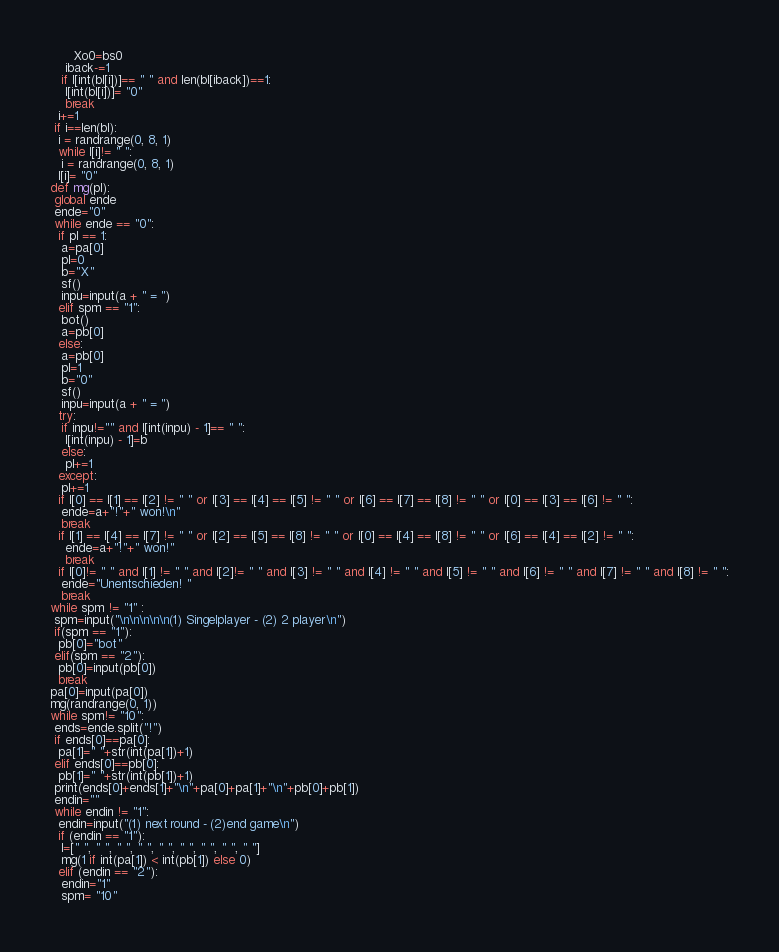<code> <loc_0><loc_0><loc_500><loc_500><_Python_>      Xo0=bs0
    iback-=1
   if l[int(bl[i])]== " " and len(bl[iback])==1:
    l[int(bl[i])]= "0"
    break
  i+=1
 if i==len(bl):
  i = randrange(0, 8, 1)
  while l[i]!= " ":
   i = randrange(0, 8, 1)
  l[i]= "0"
def mg(pl):
 global ende
 ende="0"
 while ende == "0":
  if pl == 1:
   a=pa[0]
   pl=0
   b="X"
   sf()
   inpu=input(a + " = ")
  elif spm == "1":
   bot()
   a=pb[0]
  else:
   a=pb[0]
   pl=1
   b="0"
   sf()
   inpu=input(a + " = ")
  try:
   if inpu!="" and l[int(inpu) - 1]== " ":
    l[int(inpu) - 1]=b
   else:
    pl+=1
  except:
   pl+=1
  if l[0] == l[1] == l[2] != " " or l[3] == l[4] == l[5] != " " or l[6] == l[7] == l[8] != " " or l[0] == l[3] == l[6] != " ":
   ende=a+"!"+" won!\n"
   break
  if l[1] == l[4] == l[7] != " " or l[2] == l[5] == l[8] != " " or l[0] == l[4] == l[8] != " " or l[6] == l[4] == l[2] != " ":
    ende=a+"!"+" won!"
    break
  if l[0]!= " " and l[1] != " " and l[2]!= " " and l[3] != " " and l[4] != " " and l[5] != " " and l[6] != " " and l[7] != " " and l[8] != " ":
   ende="Unentschieden! "
   break
while spm != "1" :
 spm=input("\n\n\n\n\n(1) Singelplayer - (2) 2 player\n")
 if(spm == "1"):
  pb[0]="bot"
 elif(spm == "2"):
  pb[0]=input(pb[0])
  break
pa[0]=input(pa[0])
mg(randrange(0, 1))
while spm!= "10":
 ends=ende.split("!")
 if ends[0]==pa[0]:
  pa[1]=" "+str(int(pa[1])+1)
 elif ends[0]==pb[0]:
  pb[1]=" "+str(int(pb[1])+1)
 print(ends[0]+ends[1]+"\n"+pa[0]+pa[1]+"\n"+pb[0]+pb[1])
 endin=""
 while endin != "1":
  endin=input("(1) next round - (2)end game\n")
  if (endin == "1"):
   l=[" ", " ", " ", " ", " ", " ", " ", " ", " "]
   mg(1 if int(pa[1]) < int(pb[1]) else 0)
  elif (endin == "2"):
   endin="1"
   spm= "10"</code> 